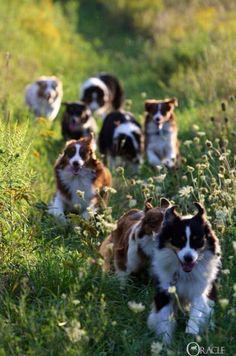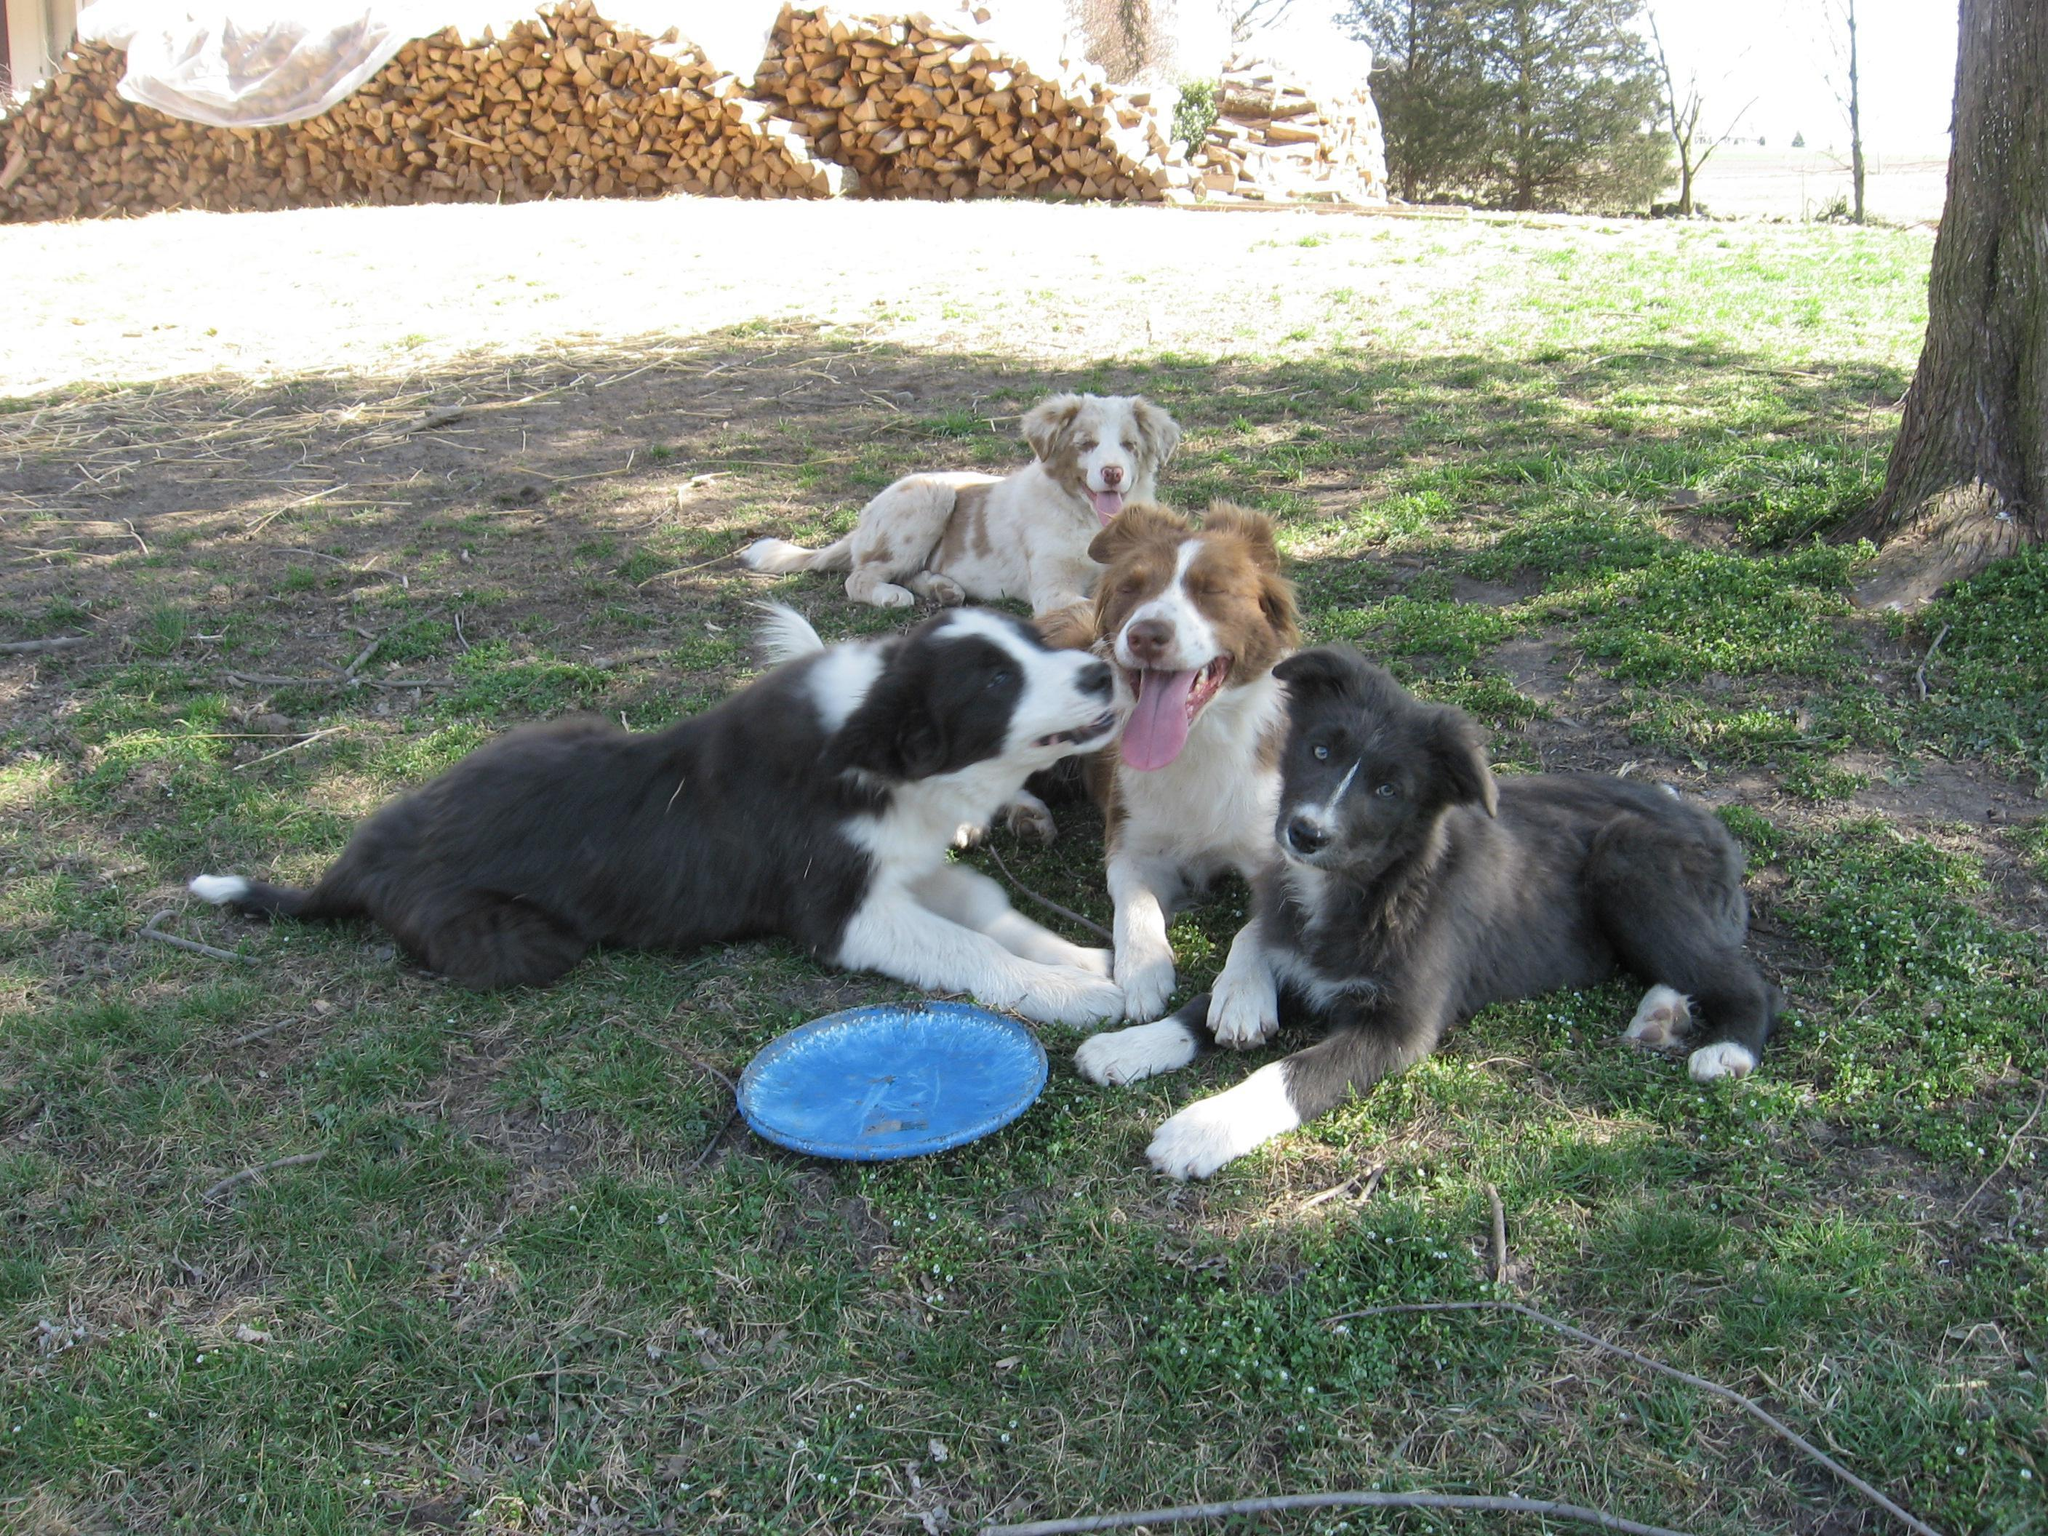The first image is the image on the left, the second image is the image on the right. Given the left and right images, does the statement "There are more dogs in the image on the right." hold true? Answer yes or no. No. 